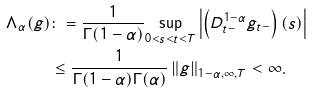Convert formula to latex. <formula><loc_0><loc_0><loc_500><loc_500>\Lambda _ { \alpha } ( g ) & \colon = \frac { 1 } { \Gamma ( 1 - \alpha ) } \underset { 0 < s < t < T } { \sup } \left | \left ( D _ { t - } ^ { 1 - \alpha } g _ { t - } \right ) ( s ) \right | \\ & \leq \frac { 1 } { \Gamma ( 1 - \alpha ) \Gamma ( \alpha ) } \left \| g \right \| _ { 1 - \alpha , \infty , T } < \infty .</formula> 